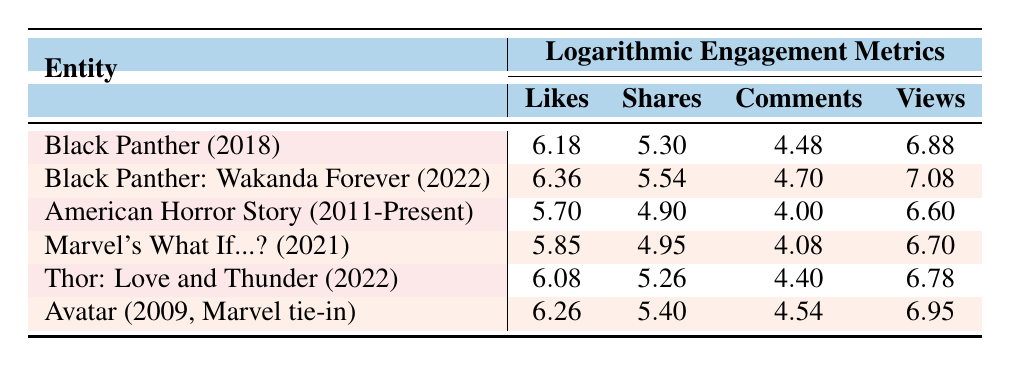What is the logarithmic value of likes for Black Panther: Wakanda Forever? The table shows that the likes for Black Panther: Wakanda Forever (2022) is listed as 6.36 under the Likes column.
Answer: 6.36 Which Marvel entity has the highest logarithmic value of views? By searching through the Views column, I find that Black Panther: Wakanda Forever (2022) has the highest value at 7.08.
Answer: 7.08 What is the difference in logarithmic comments between Thor: Love and Thunder and Marvel's What If...? The logarithmic value of comments for Thor: Love and Thunder is 4.40, and for Marvel's What If...? it is 4.08. The difference is calculated as 4.40 - 4.08 = 0.32.
Answer: 0.32 Is it true that Avatar has more likes than Black Panther? The logarithmic likes for Avatar (2009, Marvel tie-in) is 6.26, while for Black Panther (2018) it is 6.18. Hence, this statement is true since 6.26 is greater than 6.18.
Answer: Yes Which entity has more logarithmic shares: American Horror Story or Thor: Love and Thunder? The logarithmic shares for American Horror Story is 4.90, and for Thor: Love and Thunder, it is 5.26. Comparing these two values shows that 5.26 is greater than 4.90, indicating Thor: Love and Thunder has more shares.
Answer: Thor: Love and Thunder What is the average logarithmic value of likes across all entities presented? To find the average, I first sum the logarithmic likes: 6.18 + 6.36 + 5.70 + 5.85 + 6.08 + 6.26 = 36.43. Then, divide by the number of entities (6): 36.43 / 6 = 6.07.
Answer: 6.07 How many entities have a logarithmic value of comments greater than 4.40? Looking at the Comments column, the entities with values greater than 4.40 are Black Panther: Wakanda Forever (4.70), Thor: Love and Thunder (4.40), and Avatar (4.54). This totals to 3 entities, but Thor does not count, leaving 2.
Answer: 2 What is the maximum difference in logarithmic likes between any two entities? The maximum likes are for Black Panther: Wakanda Forever (6.36) and the minimum likes are for American Horror Story (5.70). Calculating the difference gives 6.36 - 5.70 = 0.66.
Answer: 0.66 